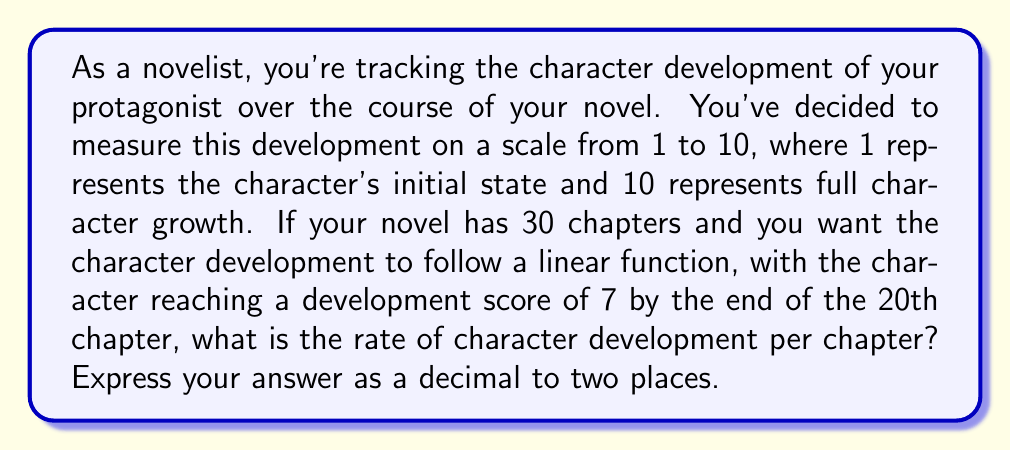What is the answer to this math problem? Let's approach this step-by-step using a linear function:

1) Let $y$ represent the character development score and $x$ represent the chapter number.

2) We can represent this linear function as $y = mx + b$, where $m$ is the rate of development per chapter and $b$ is the initial development score.

3) We know two points on this line:
   - At the beginning (chapter 0): $(0, 1)$
   - At chapter 20: $(20, 7)$

4) We can use these points to find $m$ (the rate of development):

   $$m = \frac{y_2 - y_1}{x_2 - x_1} = \frac{7 - 1}{20 - 0} = \frac{6}{20} = 0.3$$

5) To verify, let's check if this rate results in the correct development score at chapter 20:

   $y = 0.3x + 1$
   At $x = 20$: $y = 0.3(20) + 1 = 6 + 1 = 7$

Therefore, the rate of character development is 0.3 points per chapter.
Answer: 0.30 